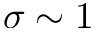<formula> <loc_0><loc_0><loc_500><loc_500>\sigma \sim 1</formula> 